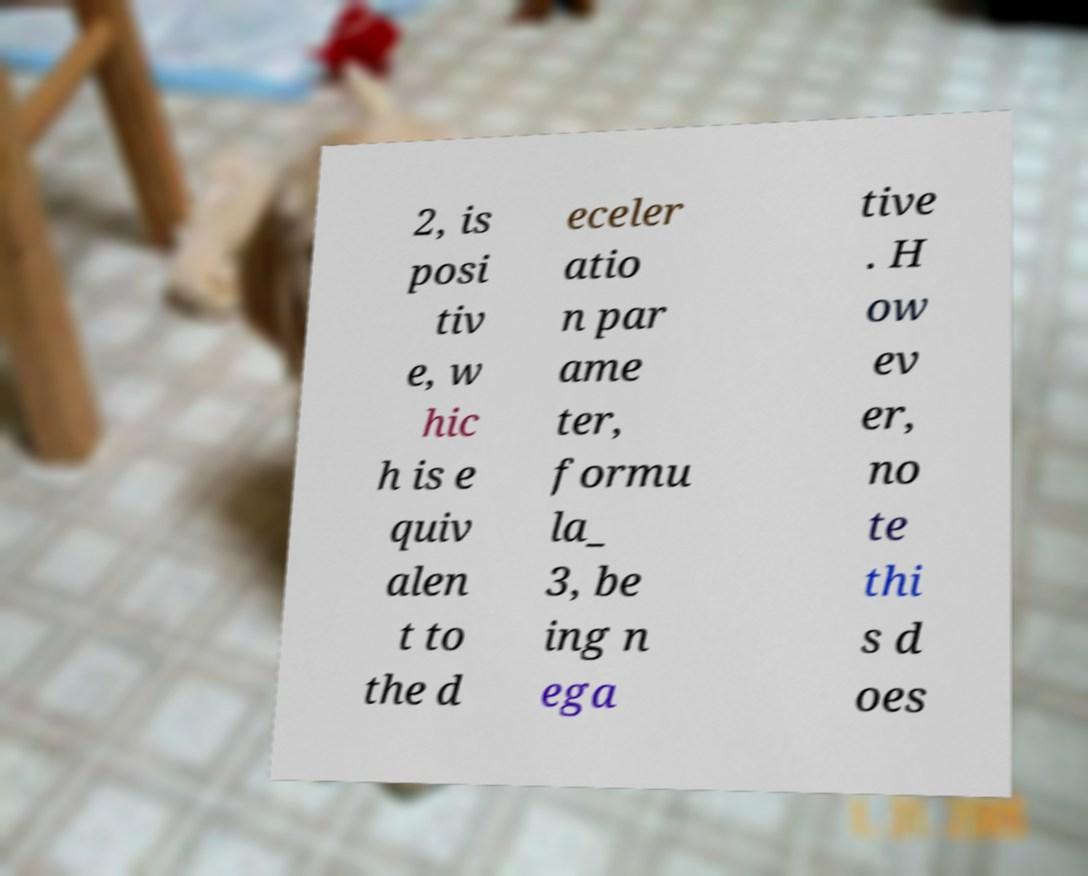I need the written content from this picture converted into text. Can you do that? 2, is posi tiv e, w hic h is e quiv alen t to the d eceler atio n par ame ter, formu la_ 3, be ing n ega tive . H ow ev er, no te thi s d oes 